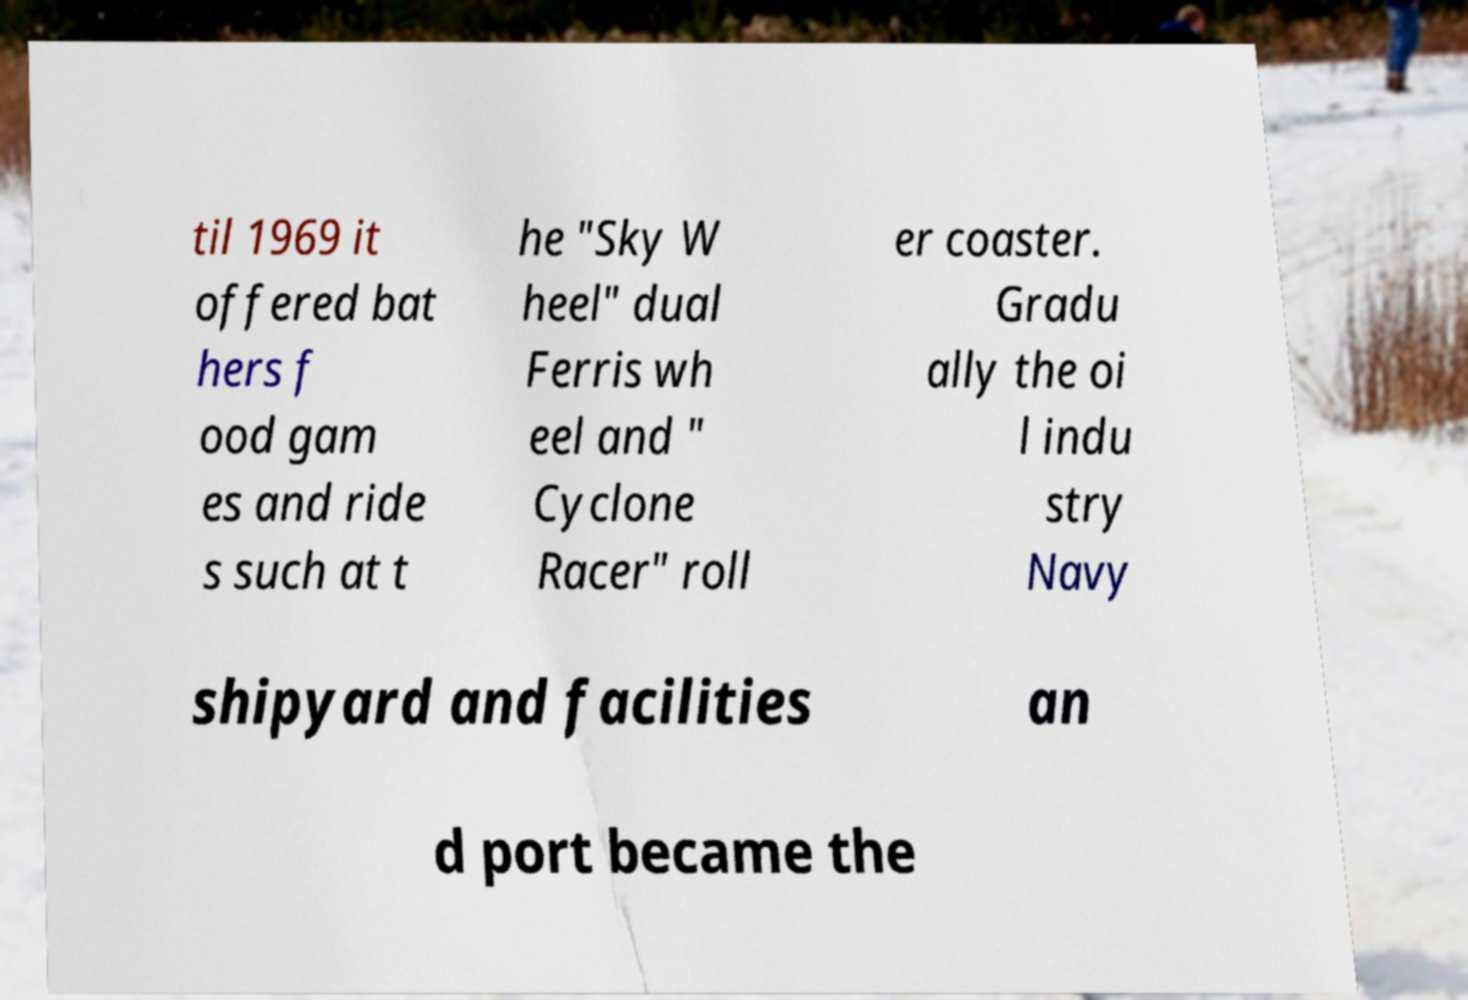I need the written content from this picture converted into text. Can you do that? til 1969 it offered bat hers f ood gam es and ride s such at t he "Sky W heel" dual Ferris wh eel and " Cyclone Racer" roll er coaster. Gradu ally the oi l indu stry Navy shipyard and facilities an d port became the 